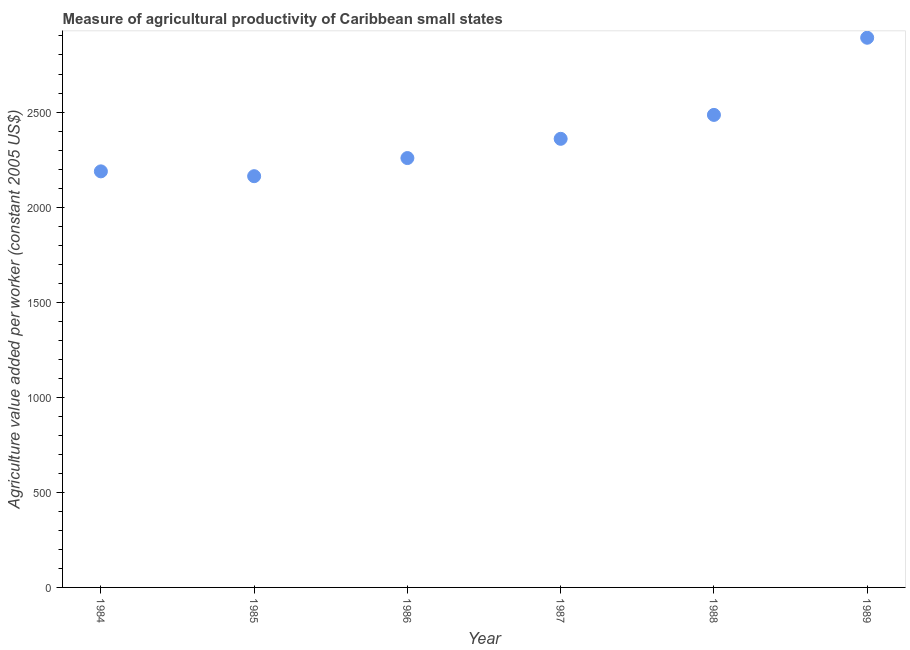What is the agriculture value added per worker in 1988?
Offer a terse response. 2484.96. Across all years, what is the maximum agriculture value added per worker?
Give a very brief answer. 2890.72. Across all years, what is the minimum agriculture value added per worker?
Your answer should be very brief. 2162.68. In which year was the agriculture value added per worker maximum?
Your answer should be compact. 1989. In which year was the agriculture value added per worker minimum?
Offer a very short reply. 1985. What is the sum of the agriculture value added per worker?
Give a very brief answer. 1.43e+04. What is the difference between the agriculture value added per worker in 1987 and 1988?
Provide a succinct answer. -125.75. What is the average agriculture value added per worker per year?
Ensure brevity in your answer.  2390.61. What is the median agriculture value added per worker?
Provide a succinct answer. 2308.61. Do a majority of the years between 1987 and 1989 (inclusive) have agriculture value added per worker greater than 200 US$?
Make the answer very short. Yes. What is the ratio of the agriculture value added per worker in 1987 to that in 1988?
Offer a very short reply. 0.95. Is the agriculture value added per worker in 1984 less than that in 1987?
Ensure brevity in your answer.  Yes. What is the difference between the highest and the second highest agriculture value added per worker?
Offer a very short reply. 405.77. What is the difference between the highest and the lowest agriculture value added per worker?
Ensure brevity in your answer.  728.04. How many years are there in the graph?
Keep it short and to the point. 6. What is the difference between two consecutive major ticks on the Y-axis?
Keep it short and to the point. 500. Are the values on the major ticks of Y-axis written in scientific E-notation?
Provide a succinct answer. No. Does the graph contain any zero values?
Provide a succinct answer. No. Does the graph contain grids?
Provide a short and direct response. No. What is the title of the graph?
Your answer should be compact. Measure of agricultural productivity of Caribbean small states. What is the label or title of the X-axis?
Your answer should be compact. Year. What is the label or title of the Y-axis?
Give a very brief answer. Agriculture value added per worker (constant 2005 US$). What is the Agriculture value added per worker (constant 2005 US$) in 1984?
Your response must be concise. 2188.07. What is the Agriculture value added per worker (constant 2005 US$) in 1985?
Your response must be concise. 2162.68. What is the Agriculture value added per worker (constant 2005 US$) in 1986?
Offer a terse response. 2258.01. What is the Agriculture value added per worker (constant 2005 US$) in 1987?
Offer a very short reply. 2359.21. What is the Agriculture value added per worker (constant 2005 US$) in 1988?
Give a very brief answer. 2484.96. What is the Agriculture value added per worker (constant 2005 US$) in 1989?
Offer a very short reply. 2890.72. What is the difference between the Agriculture value added per worker (constant 2005 US$) in 1984 and 1985?
Your response must be concise. 25.39. What is the difference between the Agriculture value added per worker (constant 2005 US$) in 1984 and 1986?
Make the answer very short. -69.95. What is the difference between the Agriculture value added per worker (constant 2005 US$) in 1984 and 1987?
Ensure brevity in your answer.  -171.14. What is the difference between the Agriculture value added per worker (constant 2005 US$) in 1984 and 1988?
Provide a succinct answer. -296.89. What is the difference between the Agriculture value added per worker (constant 2005 US$) in 1984 and 1989?
Make the answer very short. -702.66. What is the difference between the Agriculture value added per worker (constant 2005 US$) in 1985 and 1986?
Your answer should be very brief. -95.33. What is the difference between the Agriculture value added per worker (constant 2005 US$) in 1985 and 1987?
Provide a short and direct response. -196.53. What is the difference between the Agriculture value added per worker (constant 2005 US$) in 1985 and 1988?
Your response must be concise. -322.28. What is the difference between the Agriculture value added per worker (constant 2005 US$) in 1985 and 1989?
Your answer should be very brief. -728.04. What is the difference between the Agriculture value added per worker (constant 2005 US$) in 1986 and 1987?
Provide a succinct answer. -101.19. What is the difference between the Agriculture value added per worker (constant 2005 US$) in 1986 and 1988?
Your answer should be compact. -226.94. What is the difference between the Agriculture value added per worker (constant 2005 US$) in 1986 and 1989?
Give a very brief answer. -632.71. What is the difference between the Agriculture value added per worker (constant 2005 US$) in 1987 and 1988?
Your answer should be very brief. -125.75. What is the difference between the Agriculture value added per worker (constant 2005 US$) in 1987 and 1989?
Make the answer very short. -531.52. What is the difference between the Agriculture value added per worker (constant 2005 US$) in 1988 and 1989?
Provide a succinct answer. -405.77. What is the ratio of the Agriculture value added per worker (constant 2005 US$) in 1984 to that in 1985?
Offer a terse response. 1.01. What is the ratio of the Agriculture value added per worker (constant 2005 US$) in 1984 to that in 1986?
Give a very brief answer. 0.97. What is the ratio of the Agriculture value added per worker (constant 2005 US$) in 1984 to that in 1987?
Your answer should be very brief. 0.93. What is the ratio of the Agriculture value added per worker (constant 2005 US$) in 1984 to that in 1988?
Your answer should be very brief. 0.88. What is the ratio of the Agriculture value added per worker (constant 2005 US$) in 1984 to that in 1989?
Offer a very short reply. 0.76. What is the ratio of the Agriculture value added per worker (constant 2005 US$) in 1985 to that in 1986?
Your answer should be very brief. 0.96. What is the ratio of the Agriculture value added per worker (constant 2005 US$) in 1985 to that in 1987?
Give a very brief answer. 0.92. What is the ratio of the Agriculture value added per worker (constant 2005 US$) in 1985 to that in 1988?
Offer a terse response. 0.87. What is the ratio of the Agriculture value added per worker (constant 2005 US$) in 1985 to that in 1989?
Give a very brief answer. 0.75. What is the ratio of the Agriculture value added per worker (constant 2005 US$) in 1986 to that in 1988?
Make the answer very short. 0.91. What is the ratio of the Agriculture value added per worker (constant 2005 US$) in 1986 to that in 1989?
Provide a succinct answer. 0.78. What is the ratio of the Agriculture value added per worker (constant 2005 US$) in 1987 to that in 1988?
Keep it short and to the point. 0.95. What is the ratio of the Agriculture value added per worker (constant 2005 US$) in 1987 to that in 1989?
Your answer should be compact. 0.82. What is the ratio of the Agriculture value added per worker (constant 2005 US$) in 1988 to that in 1989?
Offer a terse response. 0.86. 